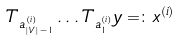<formula> <loc_0><loc_0><loc_500><loc_500>T _ { a ^ { ( i ) } _ { | V | - 1 } } \dots T _ { a ^ { ( i ) } _ { 1 } } y = \colon x ^ { ( i ) }</formula> 